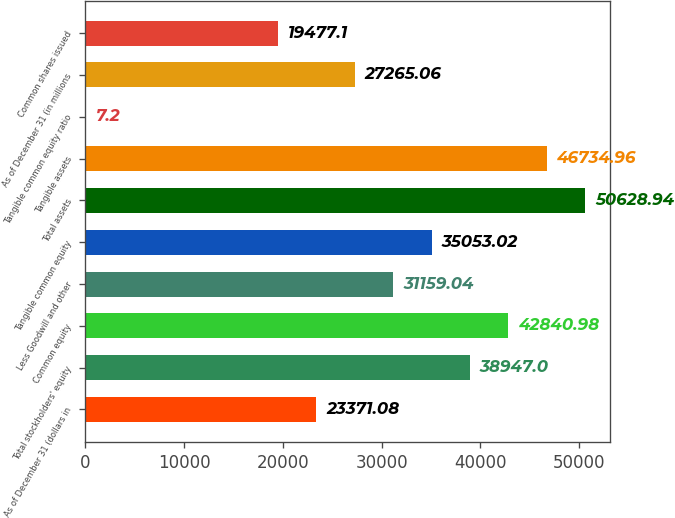Convert chart to OTSL. <chart><loc_0><loc_0><loc_500><loc_500><bar_chart><fcel>As of December 31 (dollars in<fcel>Total stockholders' equity<fcel>Common equity<fcel>Less Goodwill and other<fcel>Tangible common equity<fcel>Total assets<fcel>Tangible assets<fcel>Tangible common equity ratio<fcel>As of December 31 (in millions<fcel>Common shares issued<nl><fcel>23371.1<fcel>38947<fcel>42841<fcel>31159<fcel>35053<fcel>50628.9<fcel>46735<fcel>7.2<fcel>27265.1<fcel>19477.1<nl></chart> 